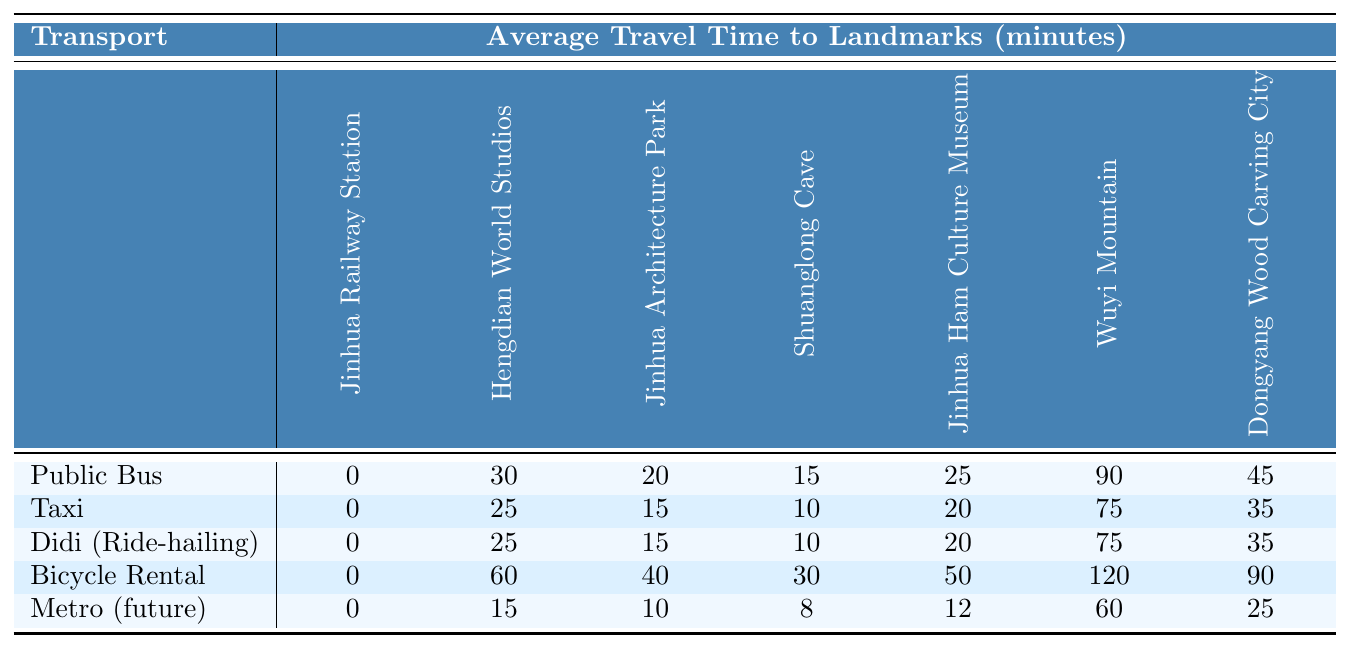What is the average travel time by taxi to Jinhua Railway Station? The travel time by taxi to Jinhua Railway Station is 0 minutes, as taxis go directly from the station.
Answer: 0 minutes How long does it take to reach Hengdian World Studios by public bus? According to the table, it takes 30 minutes by public bus to reach Hengdian World Studios.
Answer: 30 minutes Which transportation option has the shortest average travel time to Jinhua Ham Culture Museum? The table shows that the bicycle rental takes the least time, at 12 minutes, to Jinhua Ham Culture Museum.
Answer: Bicycle Rental What is the difference in average travel time between a taxi and bicycle rental to Wuyi Mountain? For a taxi, it takes 75 minutes, and for bicycle rental, it takes 120 minutes. The difference is 120 - 75 = 45 minutes.
Answer: 45 minutes Is the average travel time to Shuanglong Cave longer by Didi than by taxi? The average travel time by Didi to Shuanglong Cave is 10 minutes, while by taxi it is also 10 minutes. So, it is not longer.
Answer: No Which transportation option takes the longest time to reach Dongyang Wood Carving City? The travel time by bicycle rental is 90 minutes, which is the longest compared to all other options.
Answer: Bicycle Rental If you take a taxi to Jinhua Architecture Park, how much time would you save compared to traveling by public bus? A taxi takes 15 minutes, while a public bus takes 20 minutes. The time saved is 20 - 15 = 5 minutes.
Answer: 5 minutes How much longer does it take to reach Jinhua Ham Culture Museum by bicycle rental compared to a taxi? Bicycle rental takes 50 minutes, while taxi takes 20 minutes. The difference is 50 - 20 = 30 minutes longer.
Answer: 30 minutes What is the average travel time for all transportation options to Hengdian World Studios? The total travel times for Hengdian World Studios are: 30 (bus) + 25 (taxi) + 25 (Didi) + 60 (bicycle) + 15 (future metro) = 155 minutes. Average = 155/5 = 31 minutes.
Answer: 31 minutes Does the future metro option provide the fastest route to Jinhua Railway Station? All options to Jinhua Railway Station are 0 minutes, including future metro, which means they are equally fast.
Answer: Yes 